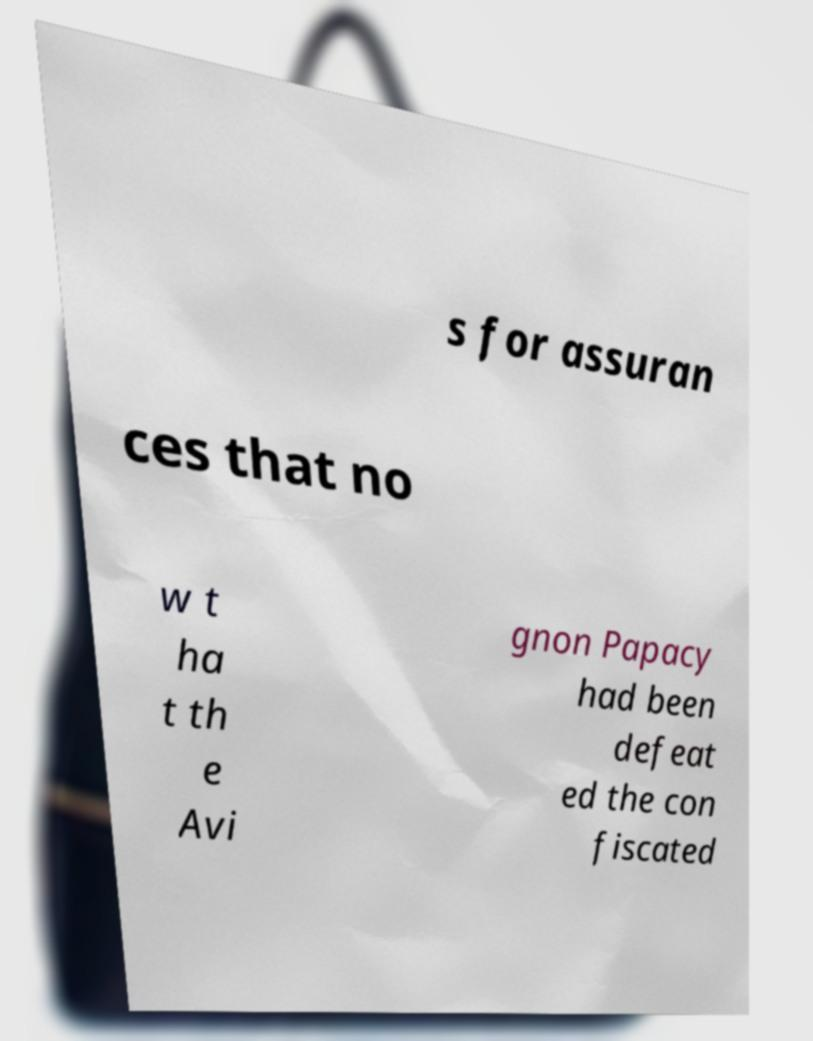For documentation purposes, I need the text within this image transcribed. Could you provide that? s for assuran ces that no w t ha t th e Avi gnon Papacy had been defeat ed the con fiscated 